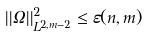<formula> <loc_0><loc_0><loc_500><loc_500>| | \Omega | | ^ { 2 } _ { L ^ { 2 , m - 2 } } \leq \varepsilon ( n , m )</formula> 